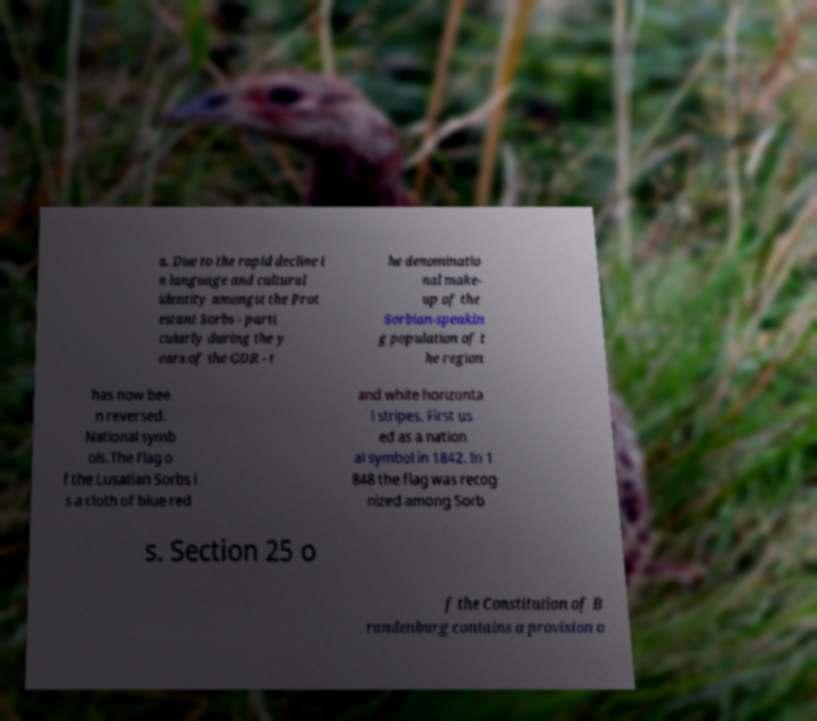What messages or text are displayed in this image? I need them in a readable, typed format. a. Due to the rapid decline i n language and cultural identity amongst the Prot estant Sorbs - parti cularly during the y ears of the GDR - t he denominatio nal make- up of the Sorbian-speakin g population of t he region has now bee n reversed. National symb ols.The flag o f the Lusatian Sorbs i s a cloth of blue red and white horizonta l stripes. First us ed as a nation al symbol in 1842. In 1 848 the flag was recog nized among Sorb s. Section 25 o f the Constitution of B randenburg contains a provision o 